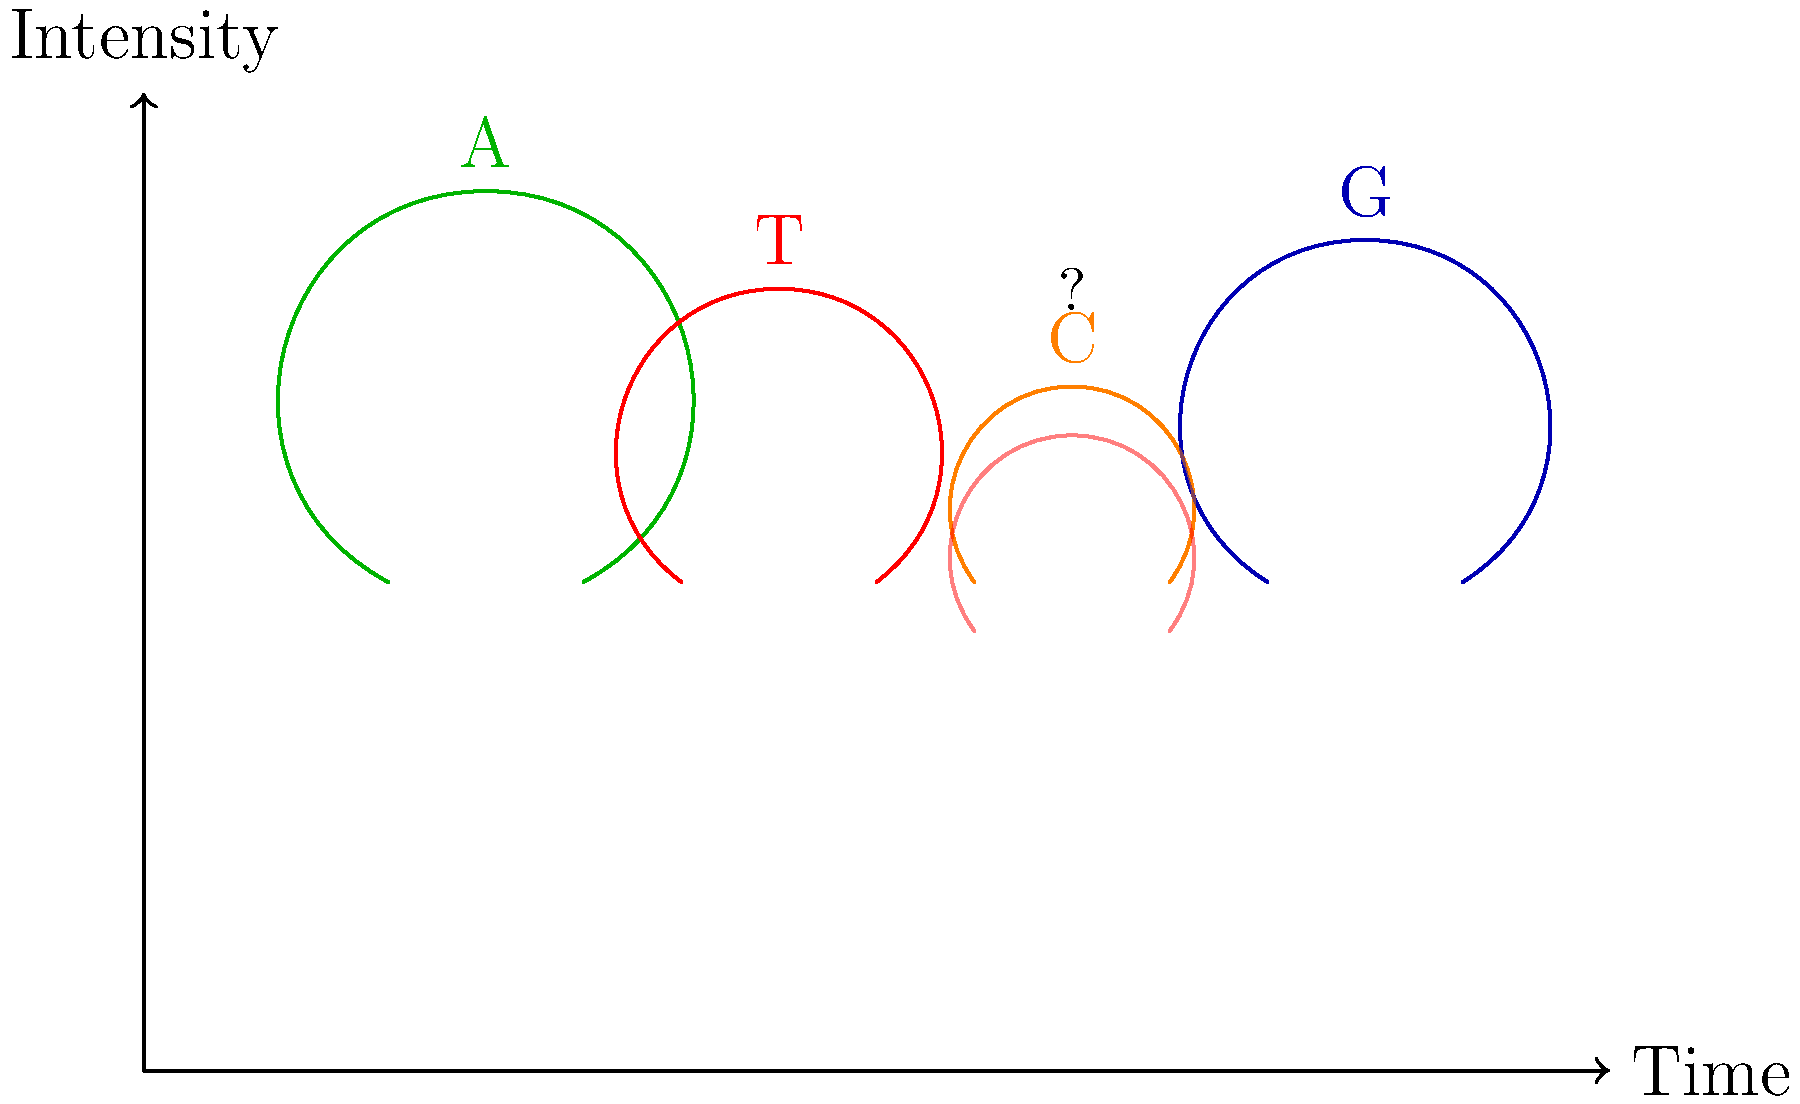Analyze the DNA sequencing electropherogram provided. What is the most likely base call for the position marked with a "?", and what does this suggest about the genetic sequence at this location? To analyze this DNA sequencing electropherogram and determine the base call for the position marked "?", we need to follow these steps:

1. Interpret the electropherogram:
   - Each peak represents a nucleotide base (A, T, C, or G).
   - The color and position of each peak indicate the specific base.
   - The height of the peak corresponds to the signal intensity.

2. Identify the bases for the clear peaks:
   - Green peak: A (Adenine)
   - Red peak: T (Thymine)
   - Orange peak: C (Cytosine)
   - Blue peak: G (Guanine)

3. Analyze the position marked "?":
   - We observe two overlapping peaks of similar height.
   - One peak appears to be orange (C) and the other red (T).

4. Interpret the overlapping peaks:
   - Overlapping peaks suggest a heterozygous position.
   - This means there are two different nucleotides at this position on the two chromosomes.

5. Determine the base call:
   - The correct base call for this position is Y.
   - In DNA sequencing, Y is the IUPAC ambiguity code for a C/T polymorphism.

6. Implications for the genetic sequence:
   - This suggests a single nucleotide polymorphism (SNP) at this location.
   - One chromosome has a C, while the other has a T.
   - This could be a heterozygous mutation or a common genetic variant.

In conclusion, the most likely base call for the position marked "?" is Y, indicating a C/T polymorphism and suggesting genetic variation at this location.
Answer: Y (C/T polymorphism) 